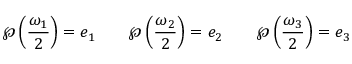Convert formula to latex. <formula><loc_0><loc_0><loc_500><loc_500>\wp \left ( { \frac { \omega _ { 1 } } { 2 } } \right ) = e _ { 1 } \quad \wp \left ( { \frac { \omega _ { 2 } } { 2 } } \right ) = e _ { 2 } \quad \wp \left ( { \frac { \omega _ { 3 } } { 2 } } \right ) = e _ { 3 }</formula> 